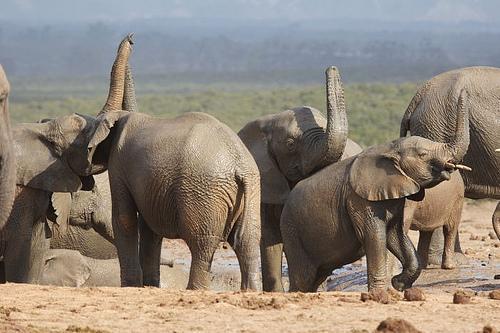What part of the body are the elephants holding up?
Pick the correct solution from the four options below to address the question.
Options: Tails, arms, ears, trunks. Trunks. 